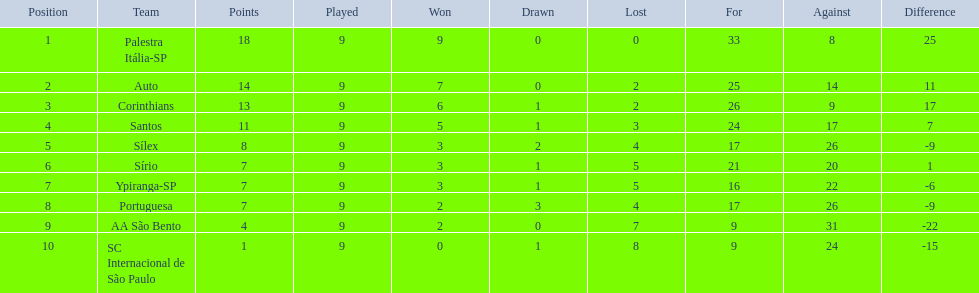How many contests did each group engage in? 9, 9, 9, 9, 9, 9, 9, 9, 9, 9. Did any group achieve 13 points in the sum of games they competed in? 13. What is the name of that group? Corinthians. 